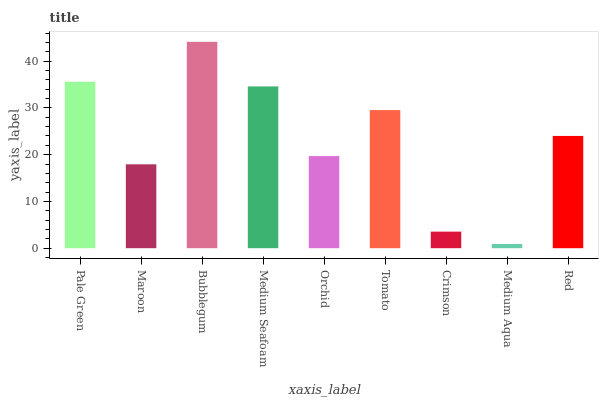Is Medium Aqua the minimum?
Answer yes or no. Yes. Is Bubblegum the maximum?
Answer yes or no. Yes. Is Maroon the minimum?
Answer yes or no. No. Is Maroon the maximum?
Answer yes or no. No. Is Pale Green greater than Maroon?
Answer yes or no. Yes. Is Maroon less than Pale Green?
Answer yes or no. Yes. Is Maroon greater than Pale Green?
Answer yes or no. No. Is Pale Green less than Maroon?
Answer yes or no. No. Is Red the high median?
Answer yes or no. Yes. Is Red the low median?
Answer yes or no. Yes. Is Bubblegum the high median?
Answer yes or no. No. Is Medium Aqua the low median?
Answer yes or no. No. 